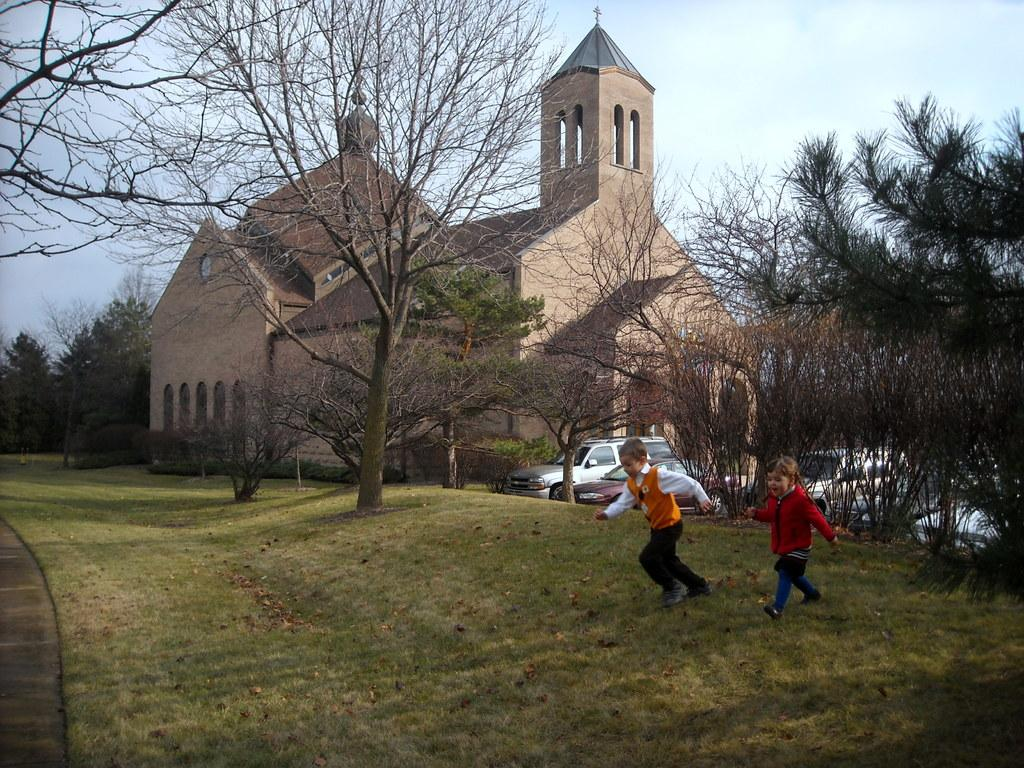What are the children in the image doing? The two children are running on the grass. What else can be seen in the image besides the children? There are vehicles and trees visible in the image. What is the architectural feature of the building in the background? The building in the background has arches. What can be seen in the sky in the image? The sky is visible in the background of the image. What type of grain is being harvested by the frog in the image? There is no frog present in the image, and therefore no grain harvesting can be observed. 